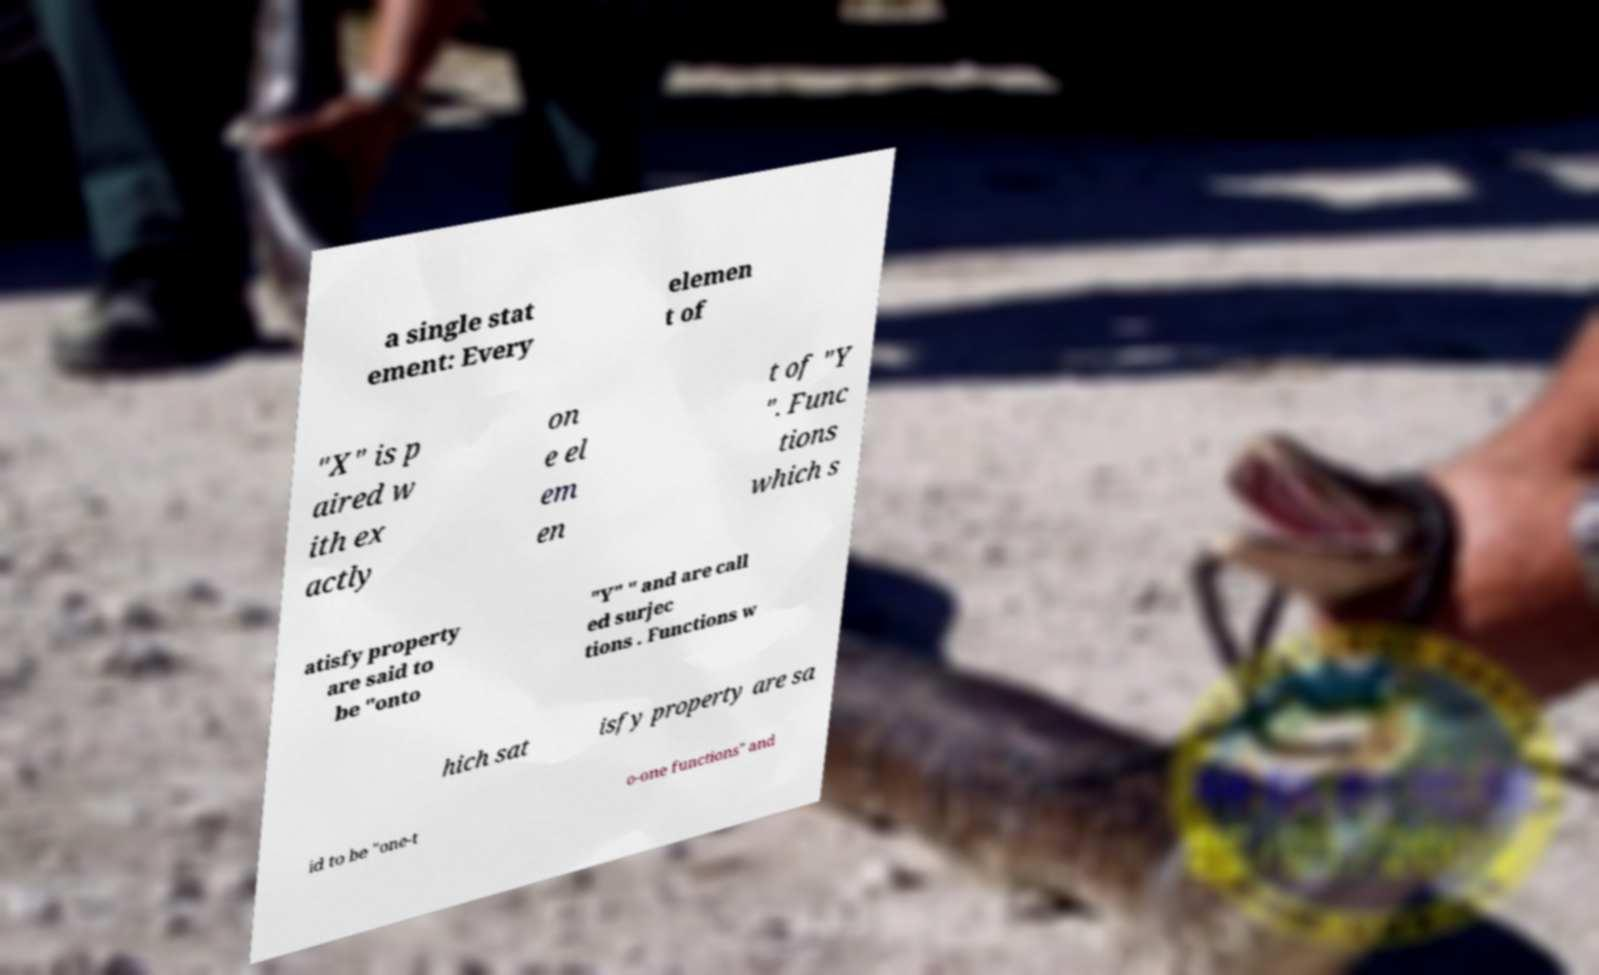Please identify and transcribe the text found in this image. a single stat ement: Every elemen t of "X" is p aired w ith ex actly on e el em en t of "Y ". Func tions which s atisfy property are said to be "onto "Y" " and are call ed surjec tions . Functions w hich sat isfy property are sa id to be "one-t o-one functions" and 